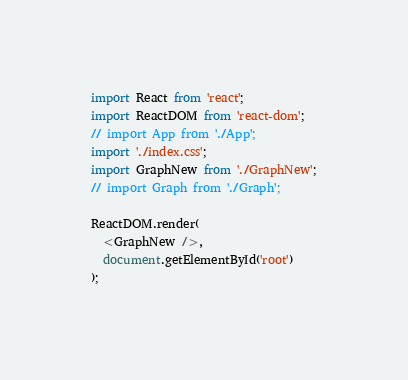Convert code to text. <code><loc_0><loc_0><loc_500><loc_500><_JavaScript_>import React from 'react';
import ReactDOM from 'react-dom';
// import App from './App';
import './index.css';
import GraphNew from './GraphNew';
// import Graph from './Graph';

ReactDOM.render(
  <GraphNew />,
  document.getElementById('root')
);
</code> 